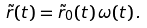Convert formula to latex. <formula><loc_0><loc_0><loc_500><loc_500>\tilde { r } ( t ) = \tilde { r } _ { 0 } ( t ) \, \omega ( t ) \, .</formula> 